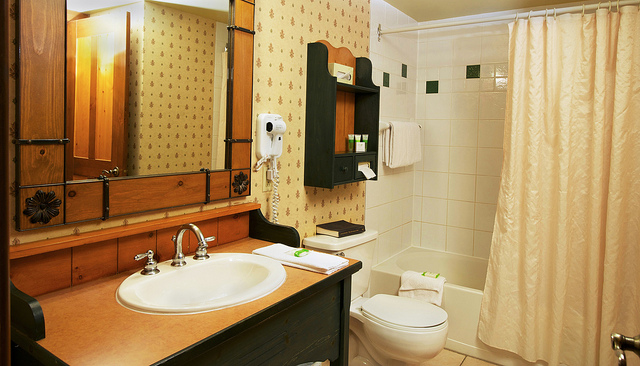How many hairdryers are in the picture? In the image, it appears that there are no hairdryers visible within the view of the bathroom presented. 